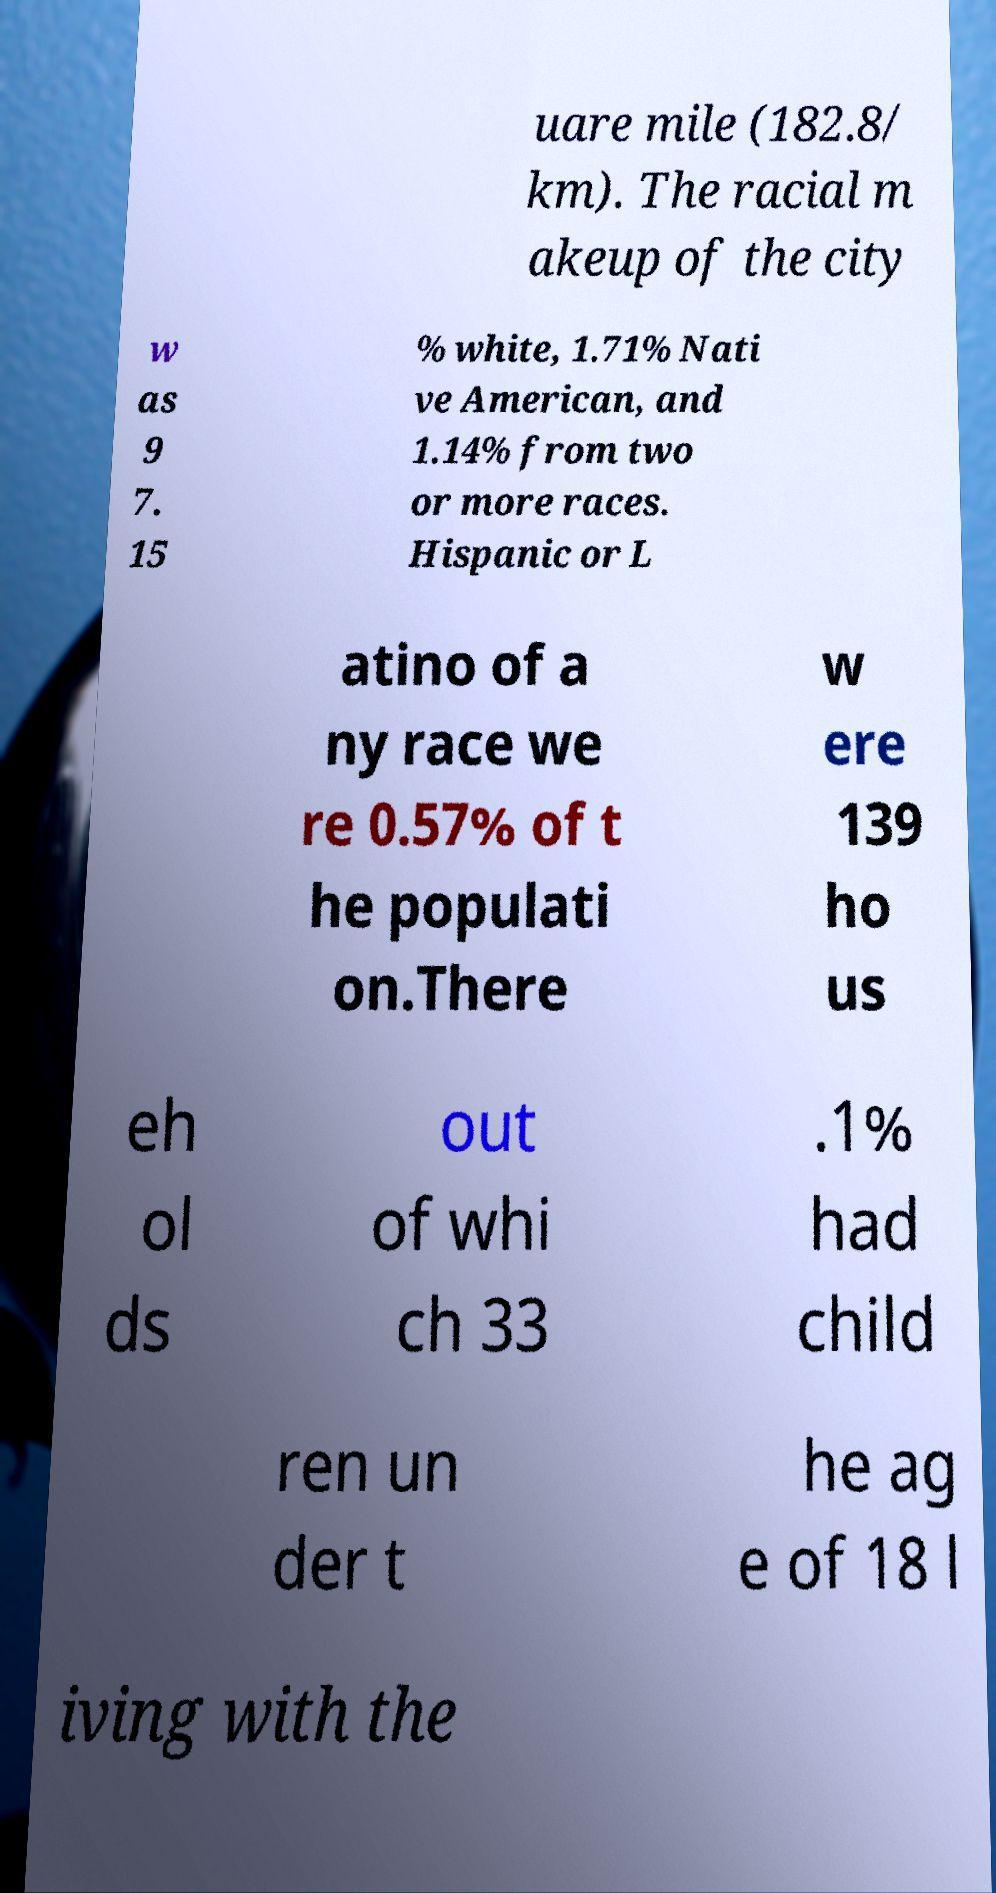Can you accurately transcribe the text from the provided image for me? uare mile (182.8/ km). The racial m akeup of the city w as 9 7. 15 % white, 1.71% Nati ve American, and 1.14% from two or more races. Hispanic or L atino of a ny race we re 0.57% of t he populati on.There w ere 139 ho us eh ol ds out of whi ch 33 .1% had child ren un der t he ag e of 18 l iving with the 